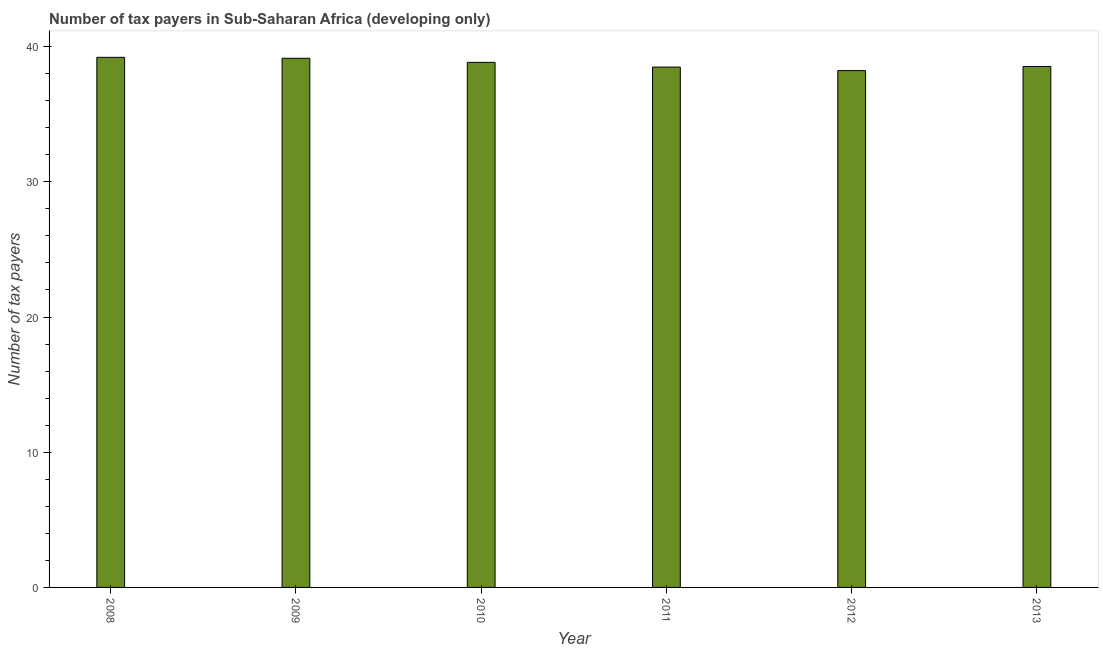What is the title of the graph?
Make the answer very short. Number of tax payers in Sub-Saharan Africa (developing only). What is the label or title of the Y-axis?
Your answer should be compact. Number of tax payers. What is the number of tax payers in 2008?
Your answer should be very brief. 39.21. Across all years, what is the maximum number of tax payers?
Provide a succinct answer. 39.21. Across all years, what is the minimum number of tax payers?
Your response must be concise. 38.23. In which year was the number of tax payers maximum?
Provide a succinct answer. 2008. What is the sum of the number of tax payers?
Ensure brevity in your answer.  232.44. What is the difference between the number of tax payers in 2008 and 2011?
Your answer should be compact. 0.72. What is the average number of tax payers per year?
Provide a succinct answer. 38.74. What is the median number of tax payers?
Keep it short and to the point. 38.69. In how many years, is the number of tax payers greater than 18 ?
Ensure brevity in your answer.  6. Is the number of tax payers in 2008 less than that in 2012?
Your answer should be compact. No. Is the difference between the number of tax payers in 2012 and 2013 greater than the difference between any two years?
Your answer should be very brief. No. What is the difference between the highest and the second highest number of tax payers?
Make the answer very short. 0.07. Are all the bars in the graph horizontal?
Offer a very short reply. No. Are the values on the major ticks of Y-axis written in scientific E-notation?
Offer a very short reply. No. What is the Number of tax payers of 2008?
Keep it short and to the point. 39.21. What is the Number of tax payers of 2009?
Offer a terse response. 39.14. What is the Number of tax payers of 2010?
Your answer should be very brief. 38.84. What is the Number of tax payers in 2011?
Your response must be concise. 38.49. What is the Number of tax payers of 2012?
Offer a terse response. 38.23. What is the Number of tax payers of 2013?
Keep it short and to the point. 38.53. What is the difference between the Number of tax payers in 2008 and 2009?
Your response must be concise. 0.07. What is the difference between the Number of tax payers in 2008 and 2010?
Keep it short and to the point. 0.37. What is the difference between the Number of tax payers in 2008 and 2011?
Offer a very short reply. 0.72. What is the difference between the Number of tax payers in 2008 and 2012?
Ensure brevity in your answer.  0.98. What is the difference between the Number of tax payers in 2008 and 2013?
Make the answer very short. 0.68. What is the difference between the Number of tax payers in 2009 and 2010?
Provide a succinct answer. 0.3. What is the difference between the Number of tax payers in 2009 and 2011?
Provide a succinct answer. 0.65. What is the difference between the Number of tax payers in 2009 and 2012?
Your answer should be compact. 0.91. What is the difference between the Number of tax payers in 2009 and 2013?
Your answer should be compact. 0.61. What is the difference between the Number of tax payers in 2010 and 2011?
Your answer should be very brief. 0.35. What is the difference between the Number of tax payers in 2010 and 2012?
Provide a succinct answer. 0.61. What is the difference between the Number of tax payers in 2010 and 2013?
Provide a succinct answer. 0.3. What is the difference between the Number of tax payers in 2011 and 2012?
Make the answer very short. 0.26. What is the difference between the Number of tax payers in 2011 and 2013?
Your response must be concise. -0.04. What is the difference between the Number of tax payers in 2012 and 2013?
Your answer should be compact. -0.31. What is the ratio of the Number of tax payers in 2008 to that in 2009?
Give a very brief answer. 1. What is the ratio of the Number of tax payers in 2008 to that in 2010?
Offer a very short reply. 1.01. What is the ratio of the Number of tax payers in 2009 to that in 2010?
Provide a succinct answer. 1.01. What is the ratio of the Number of tax payers in 2009 to that in 2011?
Make the answer very short. 1.02. What is the ratio of the Number of tax payers in 2010 to that in 2011?
Ensure brevity in your answer.  1.01. What is the ratio of the Number of tax payers in 2010 to that in 2012?
Ensure brevity in your answer.  1.02. What is the ratio of the Number of tax payers in 2010 to that in 2013?
Give a very brief answer. 1.01. What is the ratio of the Number of tax payers in 2012 to that in 2013?
Your answer should be very brief. 0.99. 